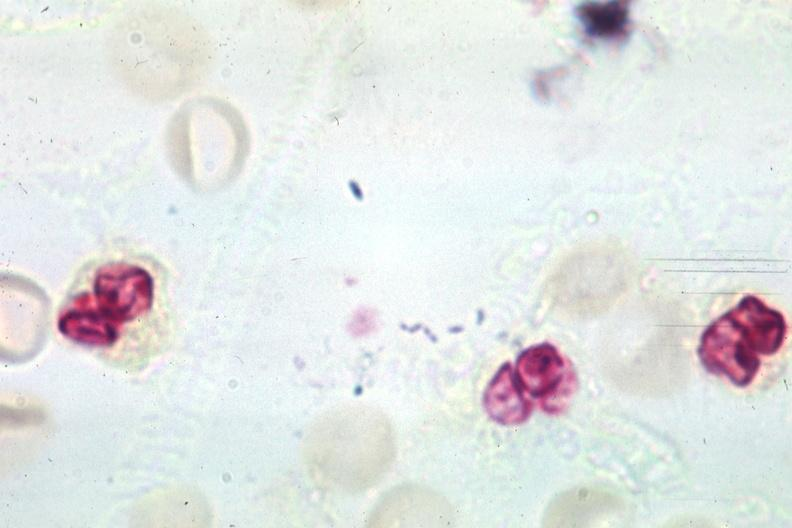s child present?
Answer the question using a single word or phrase. No 